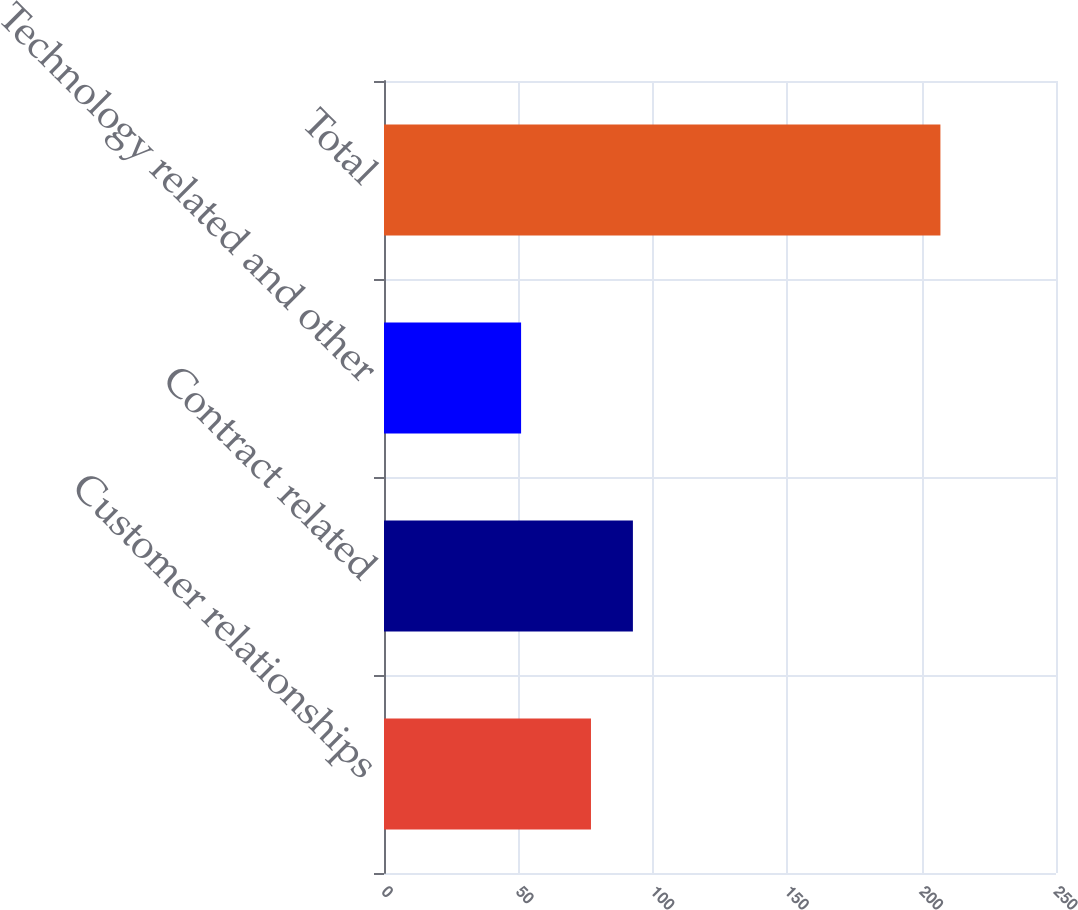Convert chart. <chart><loc_0><loc_0><loc_500><loc_500><bar_chart><fcel>Customer relationships<fcel>Contract related<fcel>Technology related and other<fcel>Total<nl><fcel>77<fcel>92.6<fcel>51<fcel>207<nl></chart> 